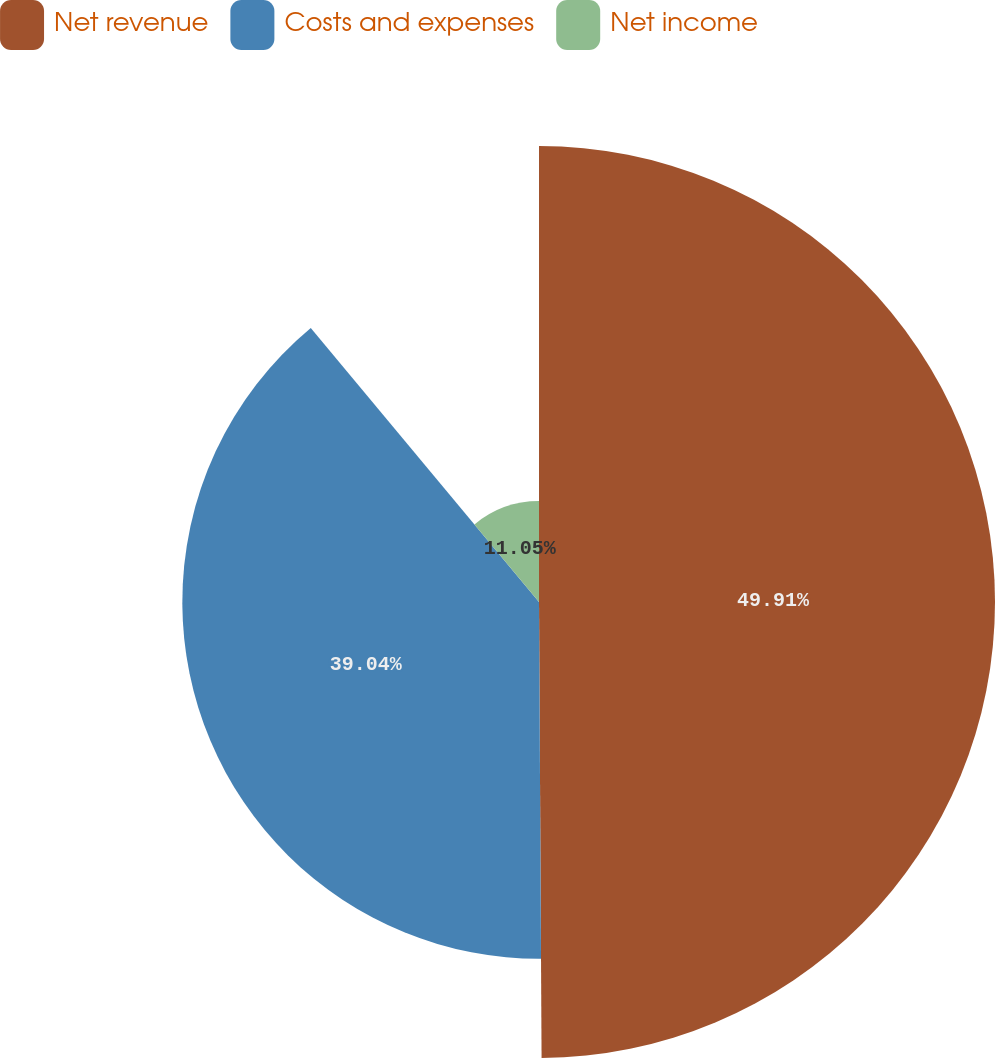Convert chart. <chart><loc_0><loc_0><loc_500><loc_500><pie_chart><fcel>Net revenue<fcel>Costs and expenses<fcel>Net income<nl><fcel>49.91%<fcel>39.04%<fcel>11.05%<nl></chart> 